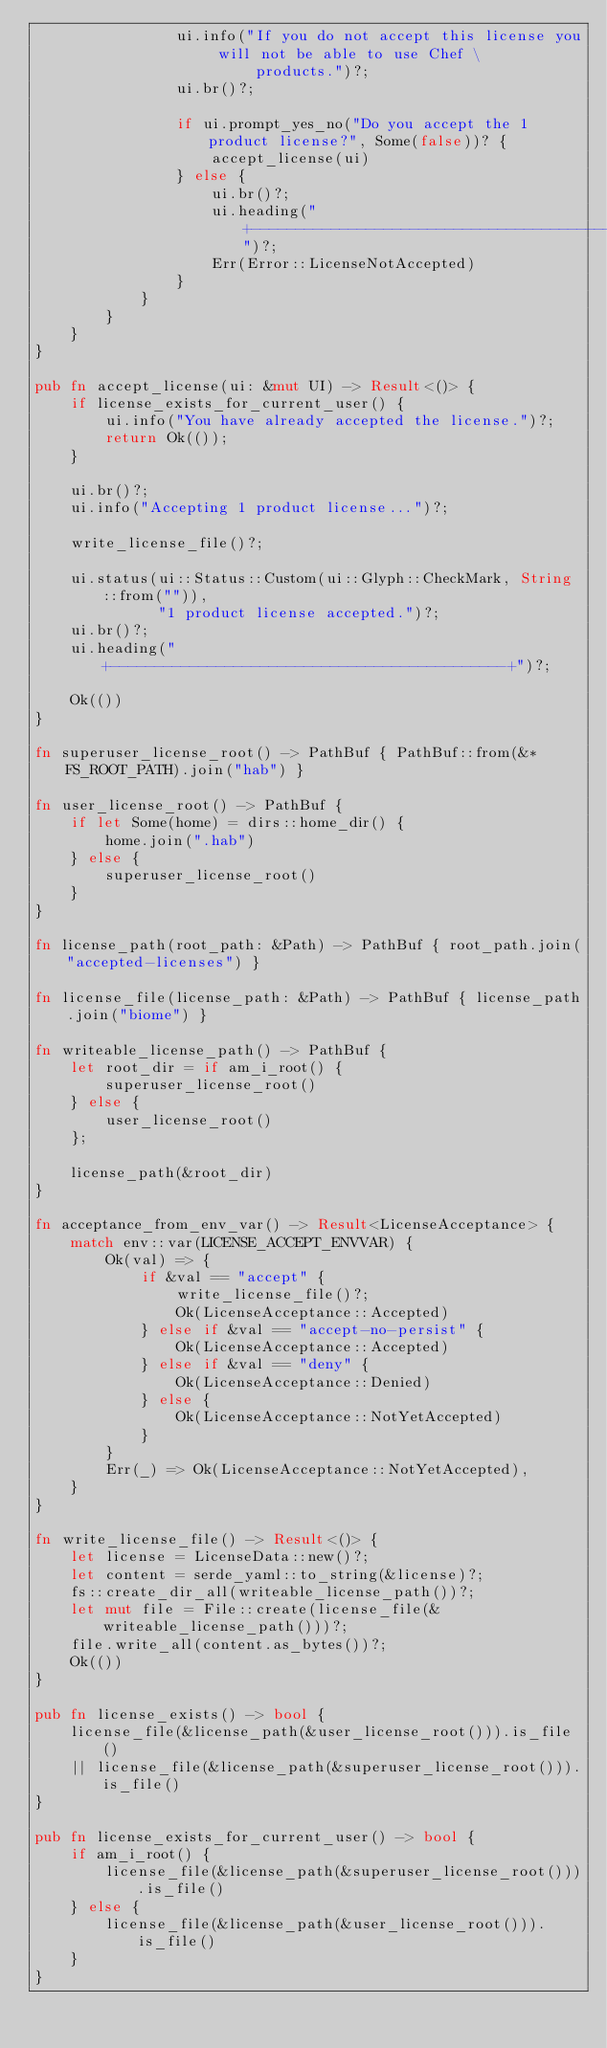<code> <loc_0><loc_0><loc_500><loc_500><_Rust_>                ui.info("If you do not accept this license you will not be able to use Chef \
                         products.")?;
                ui.br()?;

                if ui.prompt_yes_no("Do you accept the 1 product license?", Some(false))? {
                    accept_license(ui)
                } else {
                    ui.br()?;
                    ui.heading("+---------------------------------------------+")?;
                    Err(Error::LicenseNotAccepted)
                }
            }
        }
    }
}

pub fn accept_license(ui: &mut UI) -> Result<()> {
    if license_exists_for_current_user() {
        ui.info("You have already accepted the license.")?;
        return Ok(());
    }

    ui.br()?;
    ui.info("Accepting 1 product license...")?;

    write_license_file()?;

    ui.status(ui::Status::Custom(ui::Glyph::CheckMark, String::from("")),
              "1 product license accepted.")?;
    ui.br()?;
    ui.heading("+---------------------------------------------+")?;

    Ok(())
}

fn superuser_license_root() -> PathBuf { PathBuf::from(&*FS_ROOT_PATH).join("hab") }

fn user_license_root() -> PathBuf {
    if let Some(home) = dirs::home_dir() {
        home.join(".hab")
    } else {
        superuser_license_root()
    }
}

fn license_path(root_path: &Path) -> PathBuf { root_path.join("accepted-licenses") }

fn license_file(license_path: &Path) -> PathBuf { license_path.join("biome") }

fn writeable_license_path() -> PathBuf {
    let root_dir = if am_i_root() {
        superuser_license_root()
    } else {
        user_license_root()
    };

    license_path(&root_dir)
}

fn acceptance_from_env_var() -> Result<LicenseAcceptance> {
    match env::var(LICENSE_ACCEPT_ENVVAR) {
        Ok(val) => {
            if &val == "accept" {
                write_license_file()?;
                Ok(LicenseAcceptance::Accepted)
            } else if &val == "accept-no-persist" {
                Ok(LicenseAcceptance::Accepted)
            } else if &val == "deny" {
                Ok(LicenseAcceptance::Denied)
            } else {
                Ok(LicenseAcceptance::NotYetAccepted)
            }
        }
        Err(_) => Ok(LicenseAcceptance::NotYetAccepted),
    }
}

fn write_license_file() -> Result<()> {
    let license = LicenseData::new()?;
    let content = serde_yaml::to_string(&license)?;
    fs::create_dir_all(writeable_license_path())?;
    let mut file = File::create(license_file(&writeable_license_path()))?;
    file.write_all(content.as_bytes())?;
    Ok(())
}

pub fn license_exists() -> bool {
    license_file(&license_path(&user_license_root())).is_file()
    || license_file(&license_path(&superuser_license_root())).is_file()
}

pub fn license_exists_for_current_user() -> bool {
    if am_i_root() {
        license_file(&license_path(&superuser_license_root())).is_file()
    } else {
        license_file(&license_path(&user_license_root())).is_file()
    }
}
</code> 